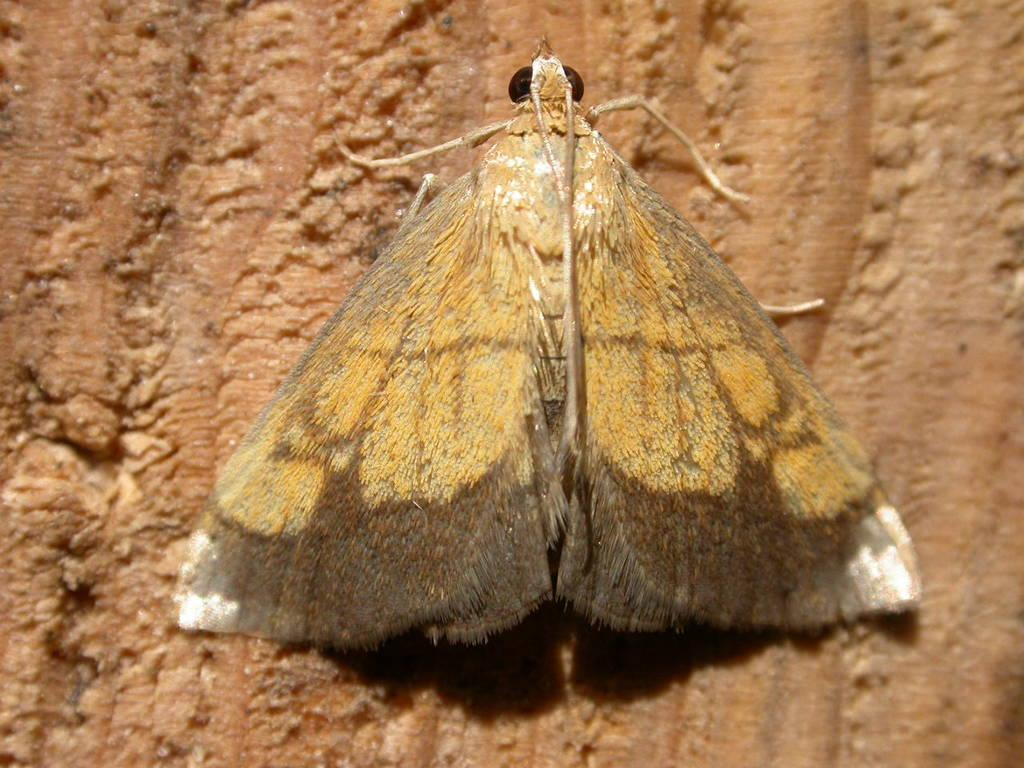What type of creature is present in the image? There is an insect in the image. What is the insect resting on in the image? The insect is on a cream-colored surface. What type of sail can be seen in the image? There is no sail present in the image; it features an insect on a cream-colored surface. Is there a battle taking place in the image? There is no battle depicted in the image; it features an insect on a cream-colored surface. 